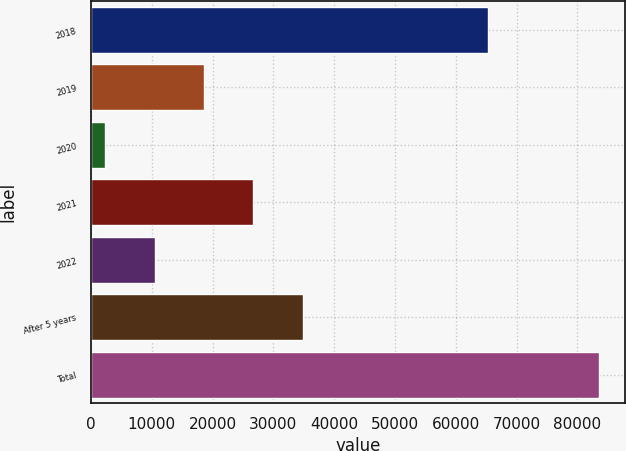<chart> <loc_0><loc_0><loc_500><loc_500><bar_chart><fcel>2018<fcel>2019<fcel>2020<fcel>2021<fcel>2022<fcel>After 5 years<fcel>Total<nl><fcel>65266<fcel>18600.2<fcel>2354<fcel>26723.3<fcel>10477.1<fcel>34846.4<fcel>83585<nl></chart> 